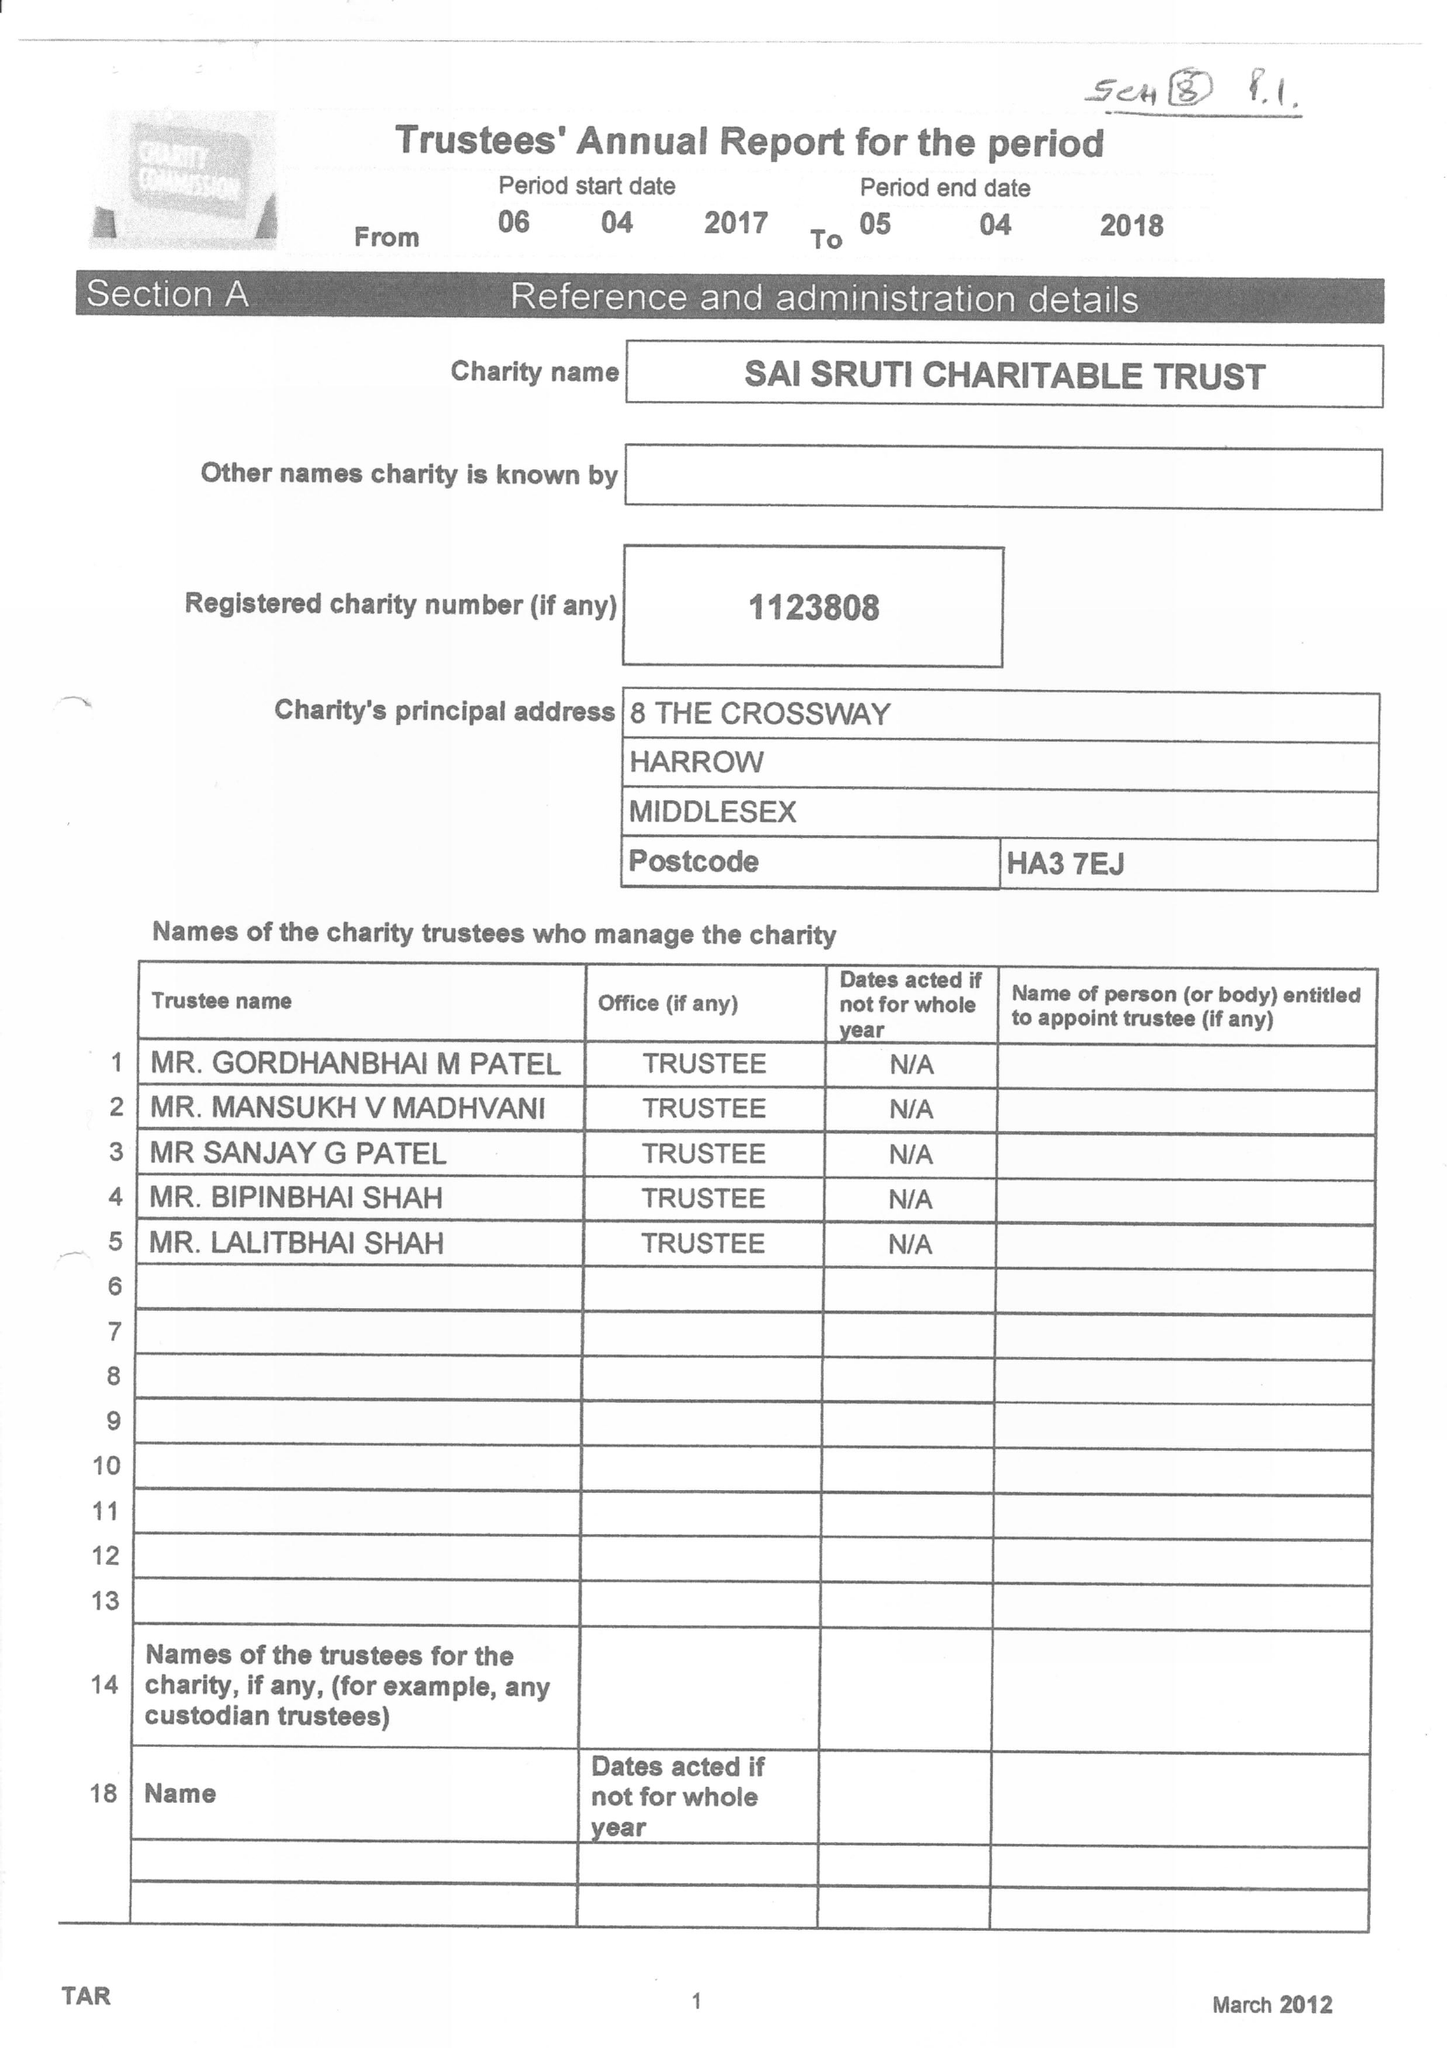What is the value for the income_annually_in_british_pounds?
Answer the question using a single word or phrase. 112381.00 